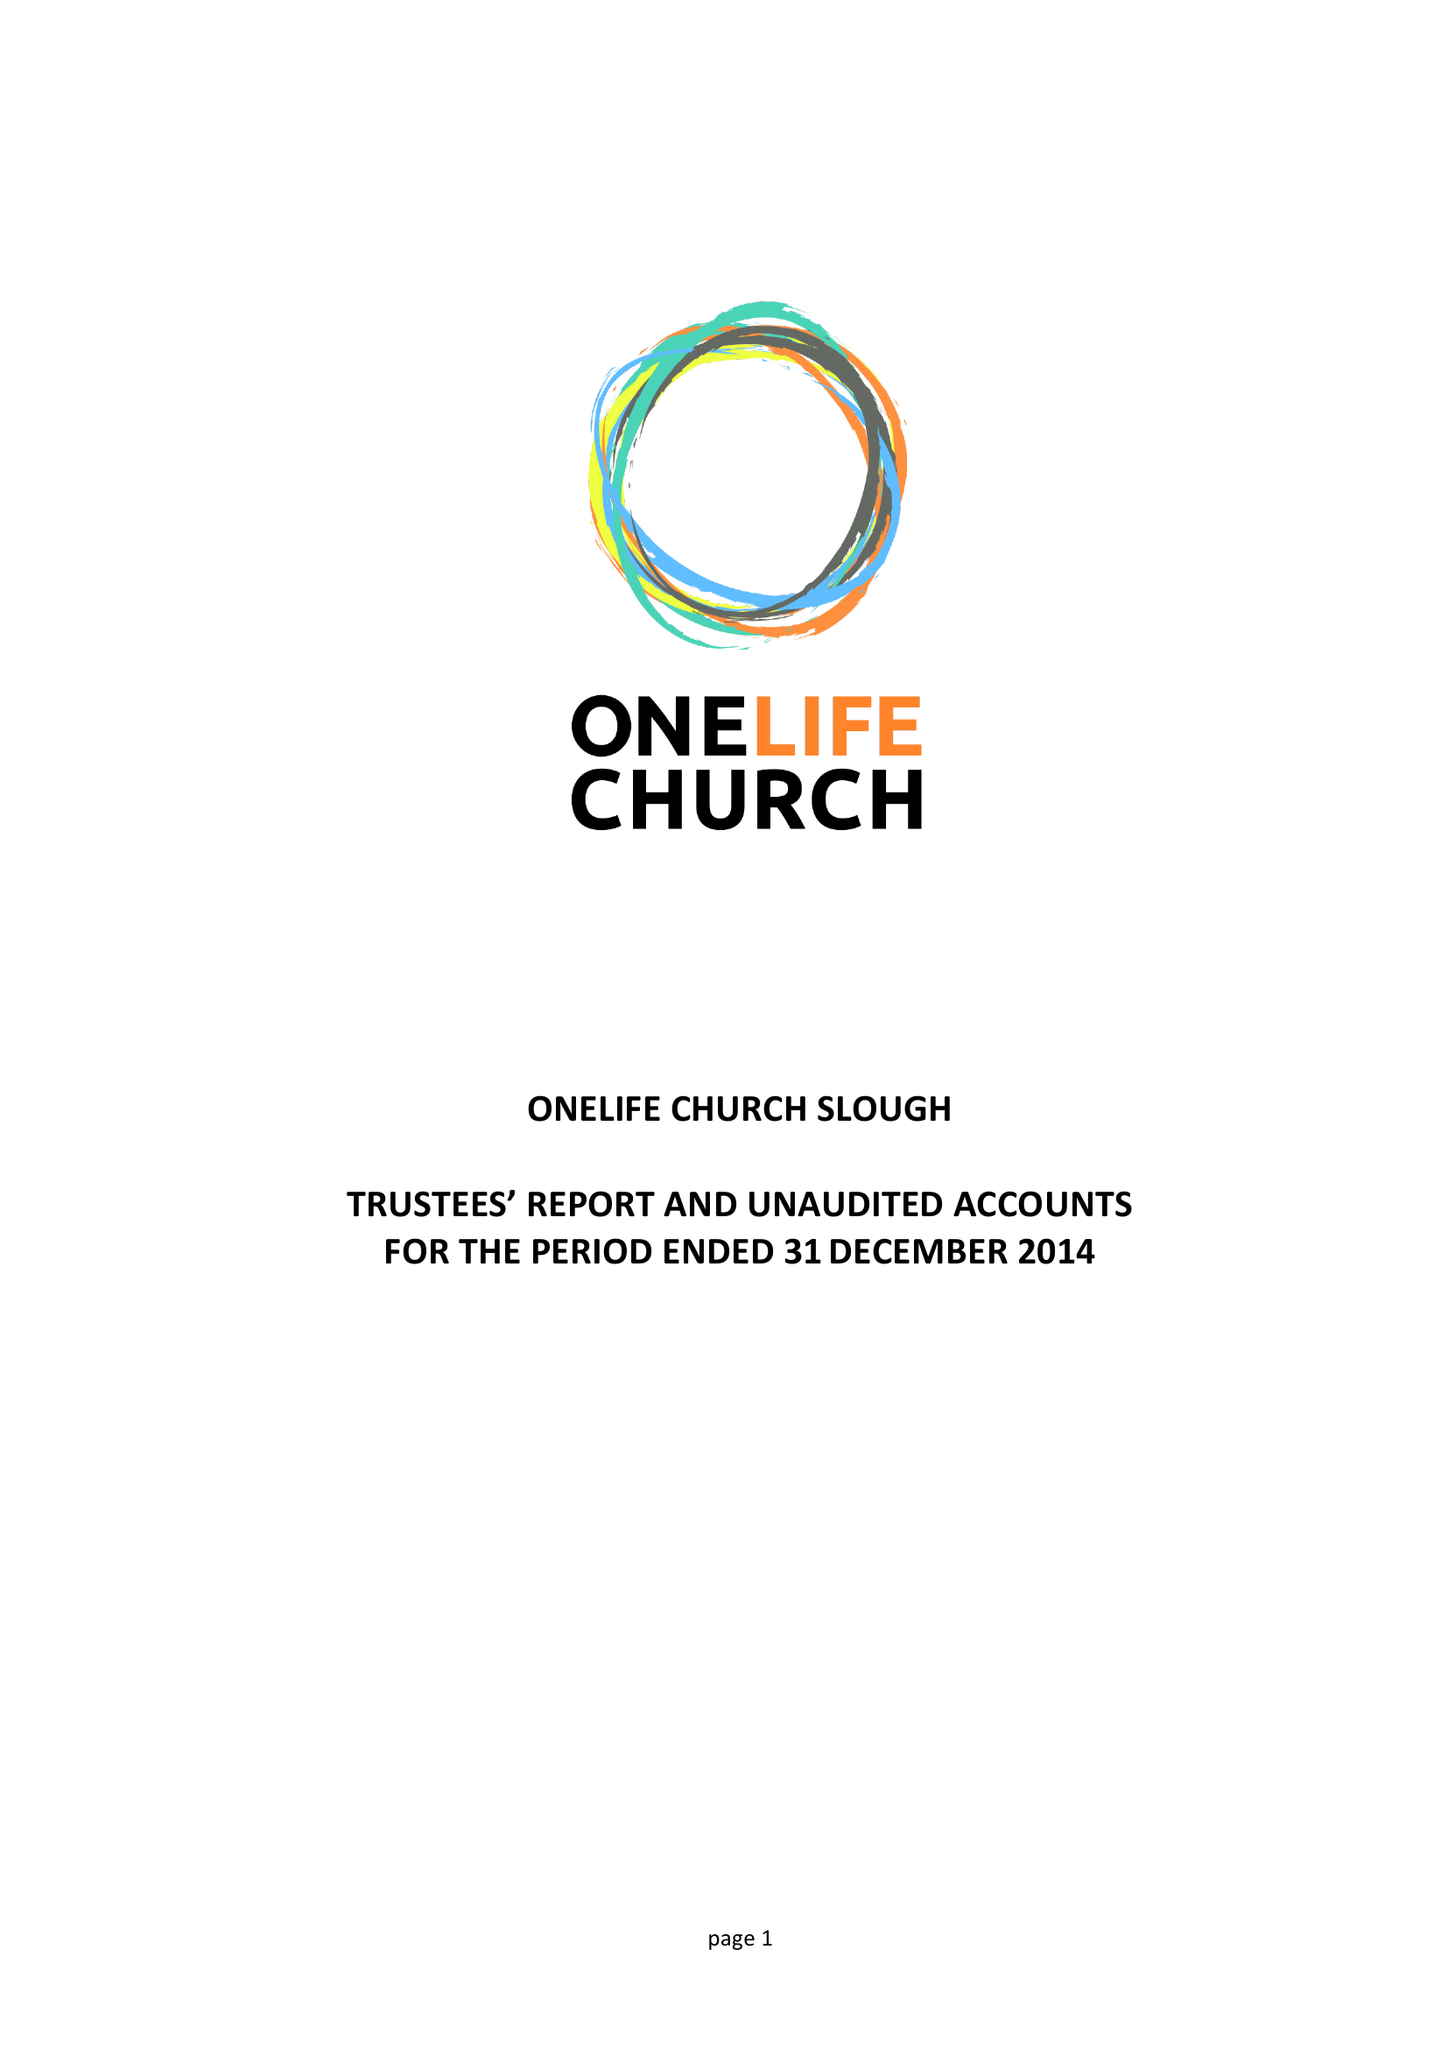What is the value for the charity_number?
Answer the question using a single word or phrase. 1156309 